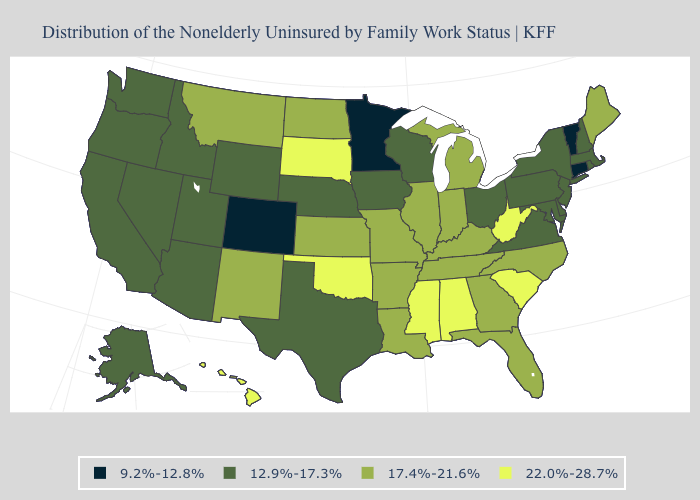What is the value of Maine?
Write a very short answer. 17.4%-21.6%. Among the states that border Maine , which have the highest value?
Give a very brief answer. New Hampshire. What is the highest value in states that border North Carolina?
Answer briefly. 22.0%-28.7%. Which states have the highest value in the USA?
Short answer required. Alabama, Hawaii, Mississippi, Oklahoma, South Carolina, South Dakota, West Virginia. What is the highest value in the USA?
Keep it brief. 22.0%-28.7%. Is the legend a continuous bar?
Short answer required. No. Name the states that have a value in the range 17.4%-21.6%?
Quick response, please. Arkansas, Florida, Georgia, Illinois, Indiana, Kansas, Kentucky, Louisiana, Maine, Michigan, Missouri, Montana, New Mexico, North Carolina, North Dakota, Tennessee. What is the value of Colorado?
Write a very short answer. 9.2%-12.8%. Which states have the lowest value in the USA?
Short answer required. Colorado, Connecticut, Minnesota, Vermont. Does Vermont have the same value as Colorado?
Quick response, please. Yes. Among the states that border Maryland , does West Virginia have the lowest value?
Write a very short answer. No. What is the value of Maryland?
Be succinct. 12.9%-17.3%. What is the lowest value in states that border Rhode Island?
Quick response, please. 9.2%-12.8%. Which states have the highest value in the USA?
Write a very short answer. Alabama, Hawaii, Mississippi, Oklahoma, South Carolina, South Dakota, West Virginia. Among the states that border Virginia , does West Virginia have the highest value?
Short answer required. Yes. 